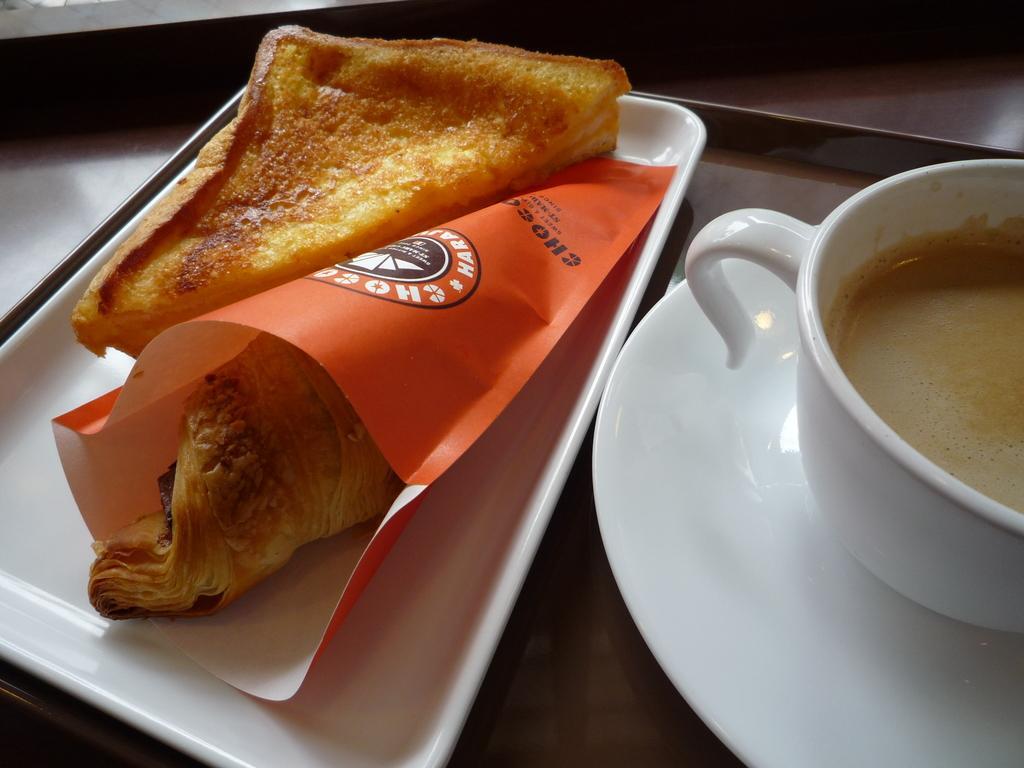Can you describe this image briefly? This is the picture of a plate in which there is a cup in the plate and a tray in which there is a bread and something in the orange cover. 